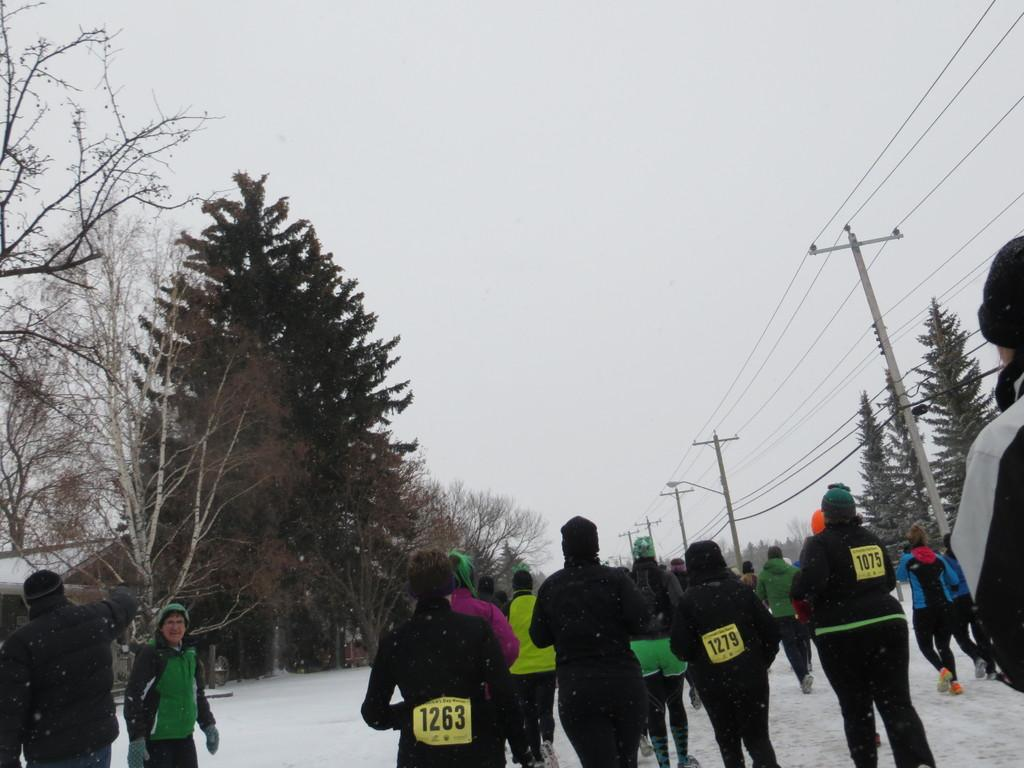How many people are in the image? There are people in the image, but the exact number is not specified. What are the people wearing on their heads? The people are wearing caps in the image. What other clothing items can be seen on the people? The people are also wearing gloves and shoes in the image. What is the weather like in the image? There is snow in the image, indicating a cold or wintry environment. What type of vegetation is present in the image? There are trees in the image. What man-made structures can be seen in the image? There are electric poles and electric wires in the image. What part of the natural environment is visible in the image? The sky is visible in the image. What type of rifle is the person holding in the image? There is no rifle present in the image; the people are wearing caps, gloves, and shoes. How many times does the person sneeze in the image? There is no indication of anyone sneezing in the image. What type of calculator is the person using in the image? There is no calculator present in the image. 